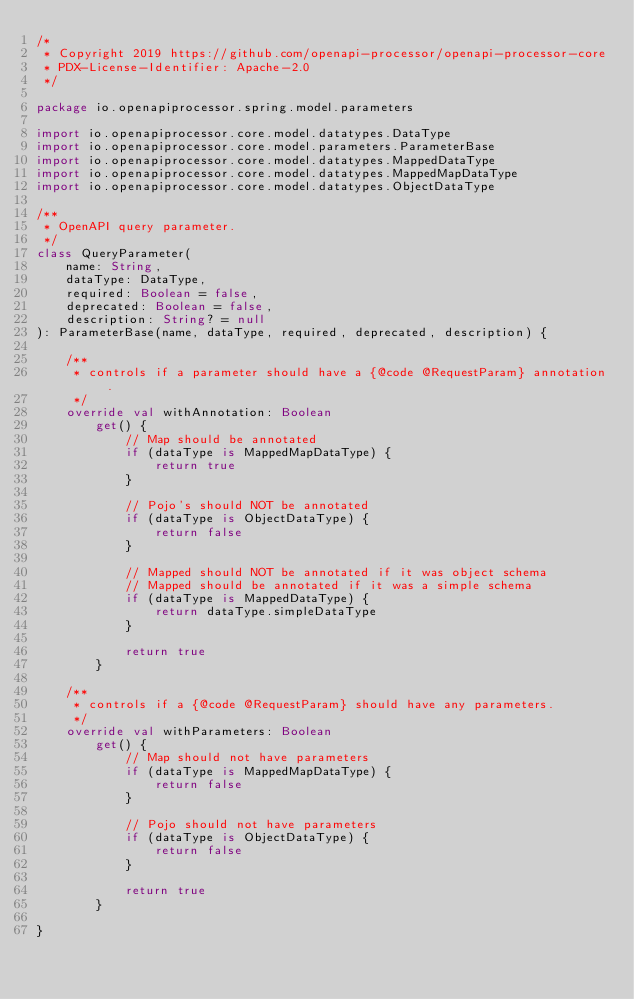Convert code to text. <code><loc_0><loc_0><loc_500><loc_500><_Kotlin_>/*
 * Copyright 2019 https://github.com/openapi-processor/openapi-processor-core
 * PDX-License-Identifier: Apache-2.0
 */

package io.openapiprocessor.spring.model.parameters

import io.openapiprocessor.core.model.datatypes.DataType
import io.openapiprocessor.core.model.parameters.ParameterBase
import io.openapiprocessor.core.model.datatypes.MappedDataType
import io.openapiprocessor.core.model.datatypes.MappedMapDataType
import io.openapiprocessor.core.model.datatypes.ObjectDataType

/**
 * OpenAPI query parameter.
 */
class QueryParameter(
    name: String,
    dataType: DataType,
    required: Boolean = false,
    deprecated: Boolean = false,
    description: String? = null
): ParameterBase(name, dataType, required, deprecated, description) {

    /**
     * controls if a parameter should have a {@code @RequestParam} annotation.
     */
    override val withAnnotation: Boolean
        get() {
            // Map should be annotated
            if (dataType is MappedMapDataType) {
                return true
            }

            // Pojo's should NOT be annotated
            if (dataType is ObjectDataType) {
                return false
            }

            // Mapped should NOT be annotated if it was object schema
            // Mapped should be annotated if it was a simple schema
            if (dataType is MappedDataType) {
                return dataType.simpleDataType
            }

            return true
        }

    /**
     * controls if a {@code @RequestParam} should have any parameters.
     */
    override val withParameters: Boolean
        get() {
            // Map should not have parameters
            if (dataType is MappedMapDataType) {
                return false
            }

            // Pojo should not have parameters
            if (dataType is ObjectDataType) {
                return false
            }

            return true
        }

}
</code> 